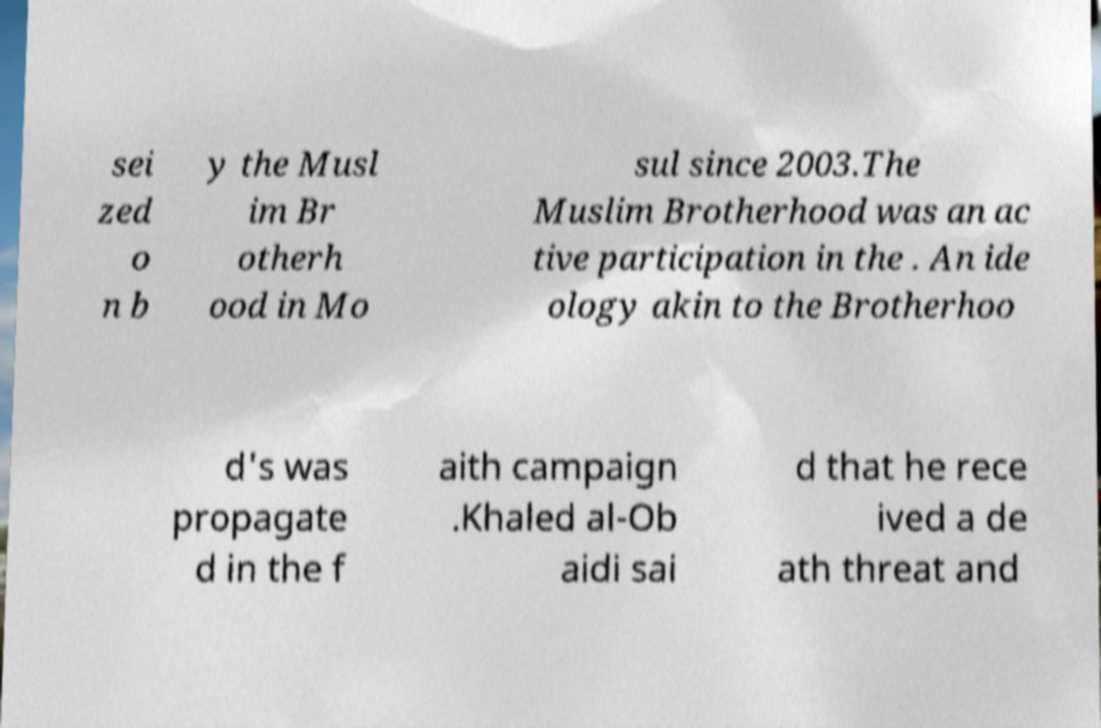Could you assist in decoding the text presented in this image and type it out clearly? sei zed o n b y the Musl im Br otherh ood in Mo sul since 2003.The Muslim Brotherhood was an ac tive participation in the . An ide ology akin to the Brotherhoo d's was propagate d in the f aith campaign .Khaled al-Ob aidi sai d that he rece ived a de ath threat and 